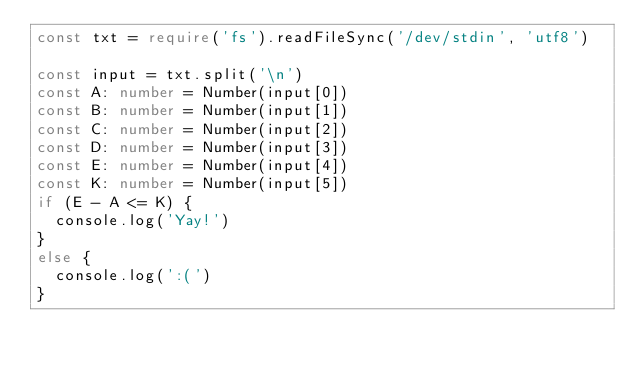Convert code to text. <code><loc_0><loc_0><loc_500><loc_500><_TypeScript_>const txt = require('fs').readFileSync('/dev/stdin', 'utf8')

const input = txt.split('\n')
const A: number = Number(input[0])
const B: number = Number(input[1])
const C: number = Number(input[2])
const D: number = Number(input[3])
const E: number = Number(input[4])
const K: number = Number(input[5])
if (E - A <= K) {
  console.log('Yay!')
}
else {
  console.log(':(')
}</code> 